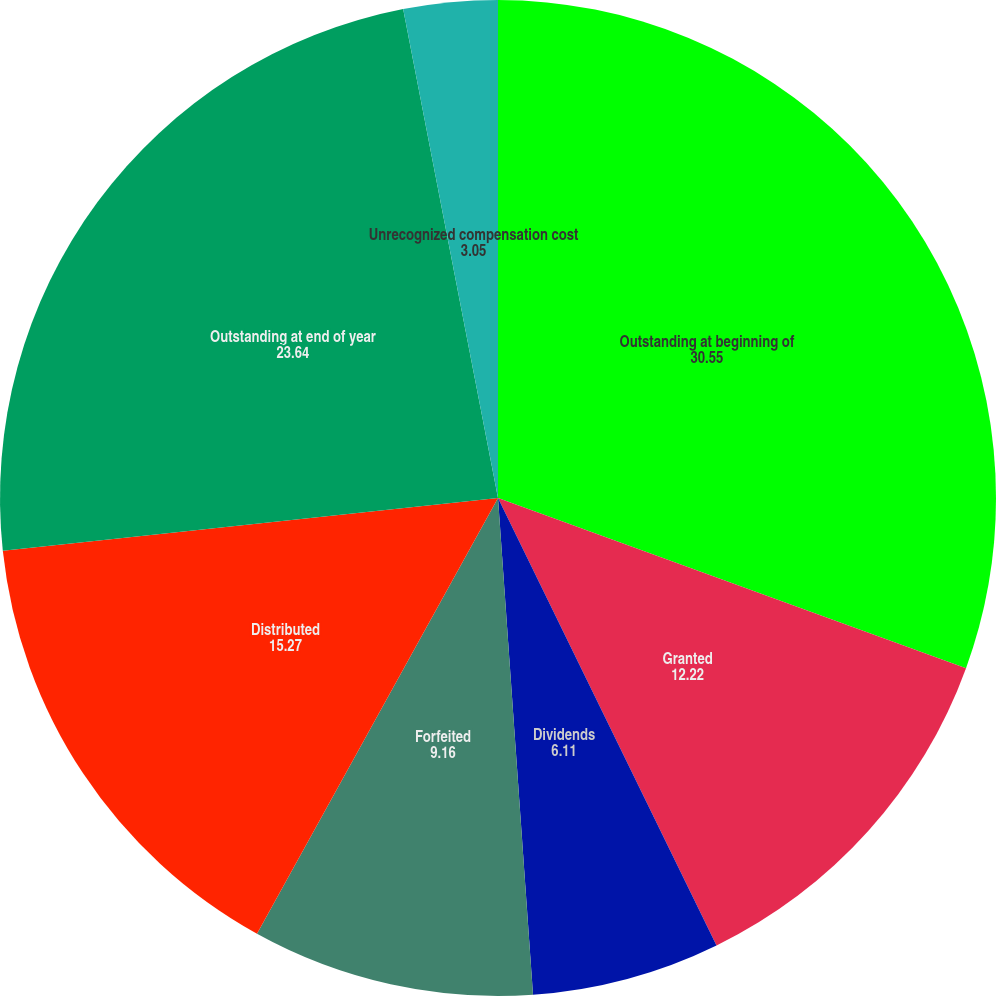<chart> <loc_0><loc_0><loc_500><loc_500><pie_chart><fcel>Outstanding at beginning of<fcel>Granted<fcel>Dividends<fcel>Forfeited<fcel>Distributed<fcel>Outstanding at end of year<fcel>Unrecognized compensation cost<fcel>Weighted average remaining<nl><fcel>30.55%<fcel>12.22%<fcel>6.11%<fcel>9.16%<fcel>15.27%<fcel>23.64%<fcel>3.05%<fcel>0.0%<nl></chart> 